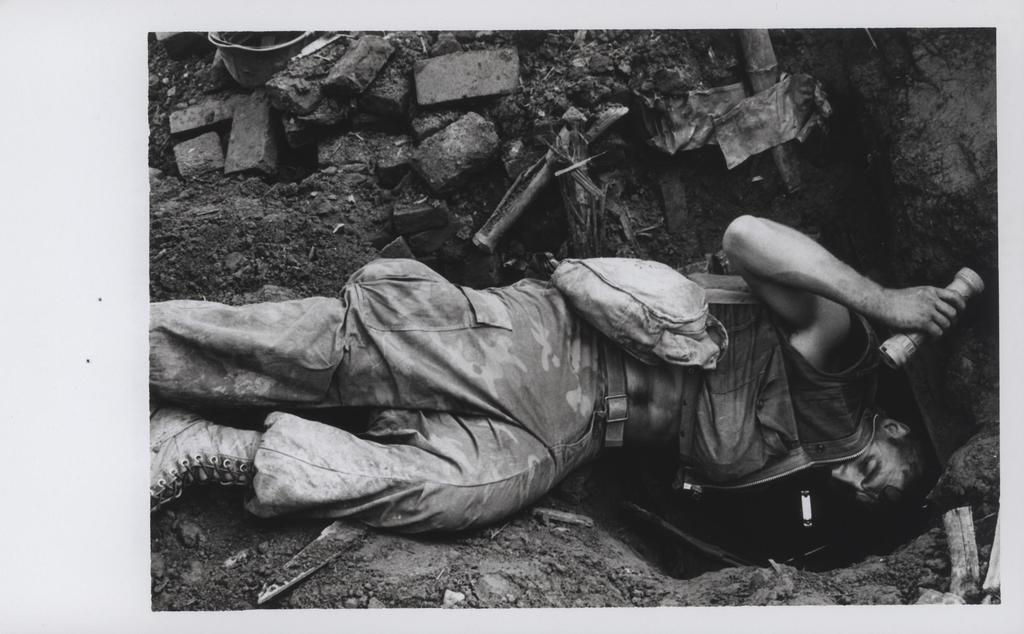What is the main subject of the image? The main subject of the image is a man. What is the man doing in the image? The man is digging the sand in the image. What type of clothing is the man wearing? The man is wearing an army dress in the image. What type of footwear is the man wearing? The man is wearing shoes in the image. What can be seen at the bottom of the image? There are stones at the bottom of the image. How many cherries can be seen in the image? There are no cherries present in the image. What is the man learning while digging the sand in the image? There is no indication in the image that the man is learning anything while digging the sand. 